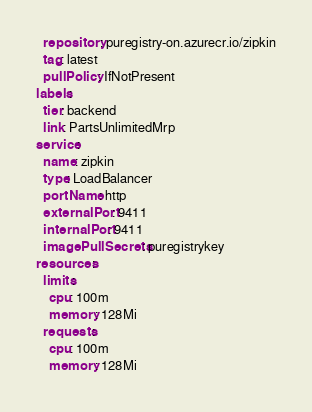<code> <loc_0><loc_0><loc_500><loc_500><_YAML_>  repository: puregistry-on.azurecr.io/zipkin
  tag: latest
  pullPolicy: IfNotPresent
labels:
  tier: backend
  link: PartsUnlimitedMrp
service:
  name: zipkin
  type: LoadBalancer
  portName: http
  externalPort: 9411
  internalPort: 9411
  imagePullSecrets: puregistrykey
resources:
  limits:
    cpu: 100m
    memory: 128Mi
  requests:
    cpu: 100m
    memory: 128Mi

</code> 